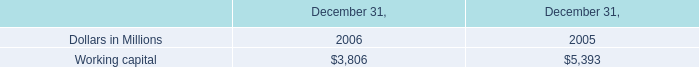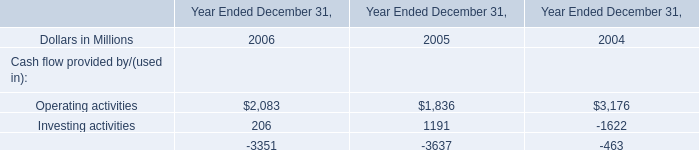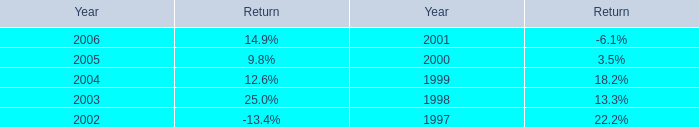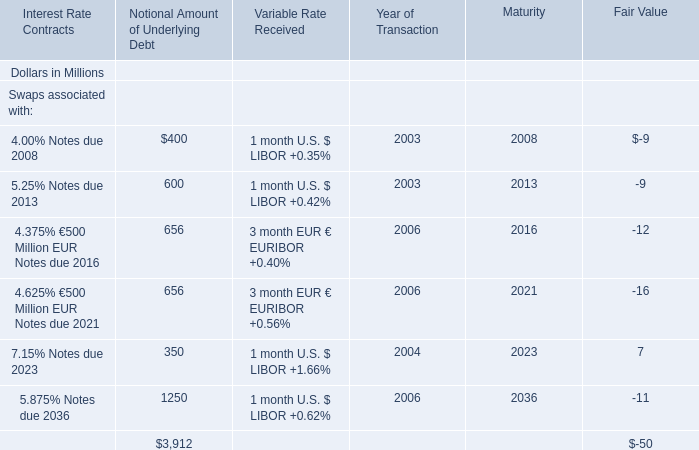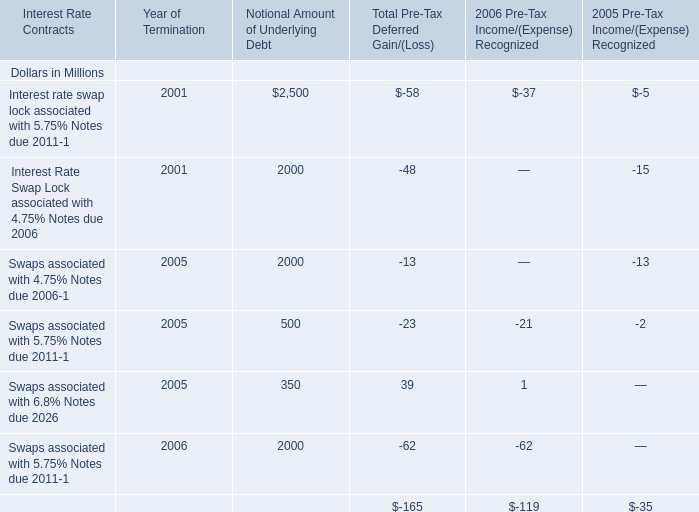What's the average of 4.625% €500 Million EUR Notes due 2021 in 2006? (in million) 
Computations: ((656 + 656) / 2)
Answer: 656.0. 